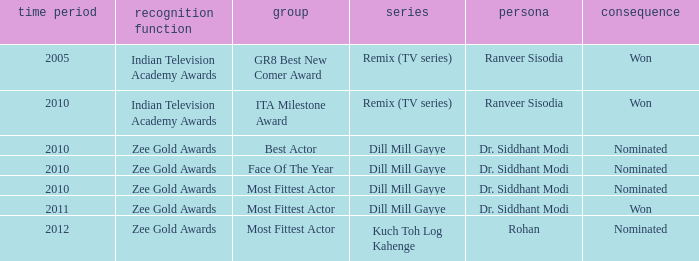Which character was nominated in the 2010 Indian Television Academy Awards? Ranveer Sisodia. 